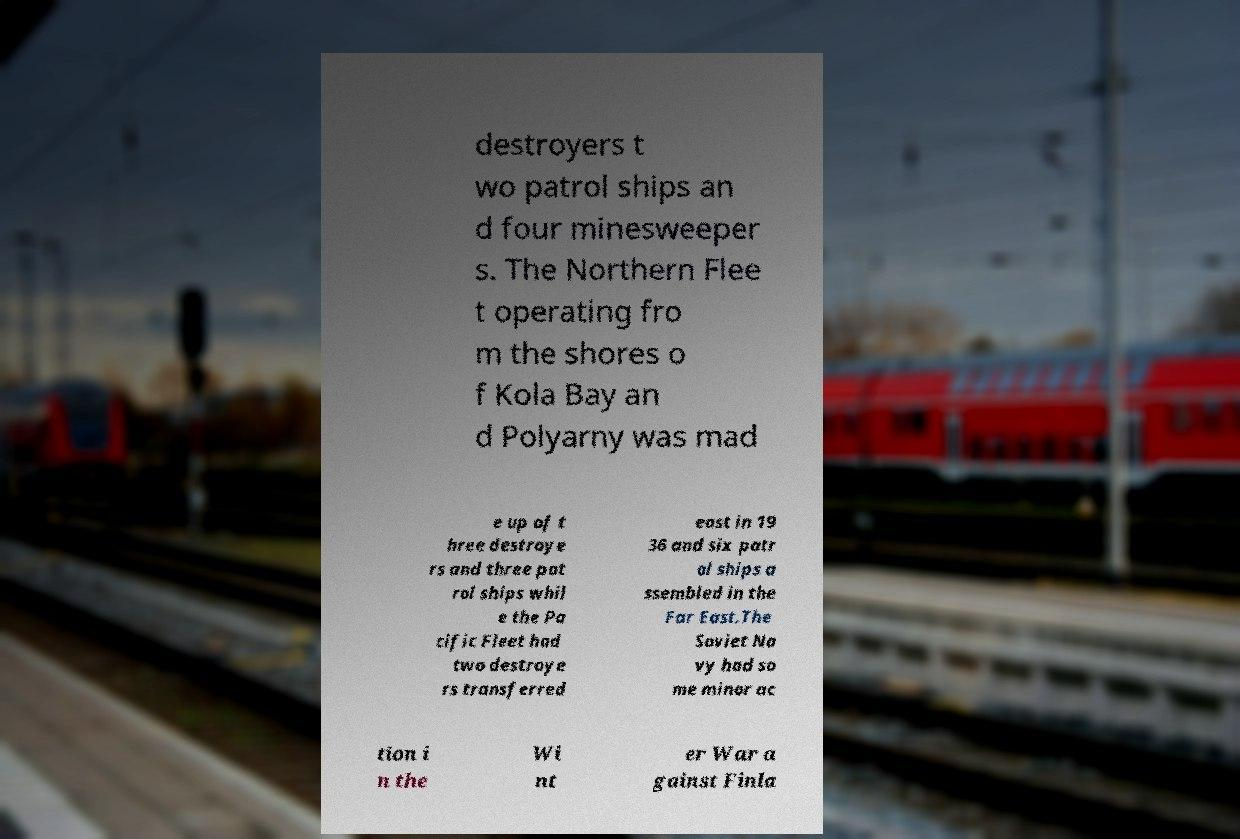There's text embedded in this image that I need extracted. Can you transcribe it verbatim? destroyers t wo patrol ships an d four minesweeper s. The Northern Flee t operating fro m the shores o f Kola Bay an d Polyarny was mad e up of t hree destroye rs and three pat rol ships whil e the Pa cific Fleet had two destroye rs transferred east in 19 36 and six patr ol ships a ssembled in the Far East.The Soviet Na vy had so me minor ac tion i n the Wi nt er War a gainst Finla 